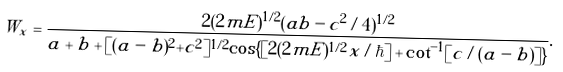Convert formula to latex. <formula><loc_0><loc_0><loc_500><loc_500>W _ { x } = \frac { 2 ( 2 m E ) ^ { 1 / 2 } ( a b - c ^ { 2 } / 4 ) ^ { 1 / 2 } } { a + b + [ ( a - b ) ^ { 2 } + c ^ { 2 } ] ^ { 1 / 2 } \cos \{ [ 2 ( 2 m E ) ^ { 1 / 2 } x / \hbar { ] } + \cot ^ { - 1 } [ c / ( a - b ) ] \} } .</formula> 